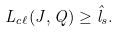<formula> <loc_0><loc_0><loc_500><loc_500>L _ { c \ell } ( J , Q ) \geq \hat { l } _ { s } .</formula> 